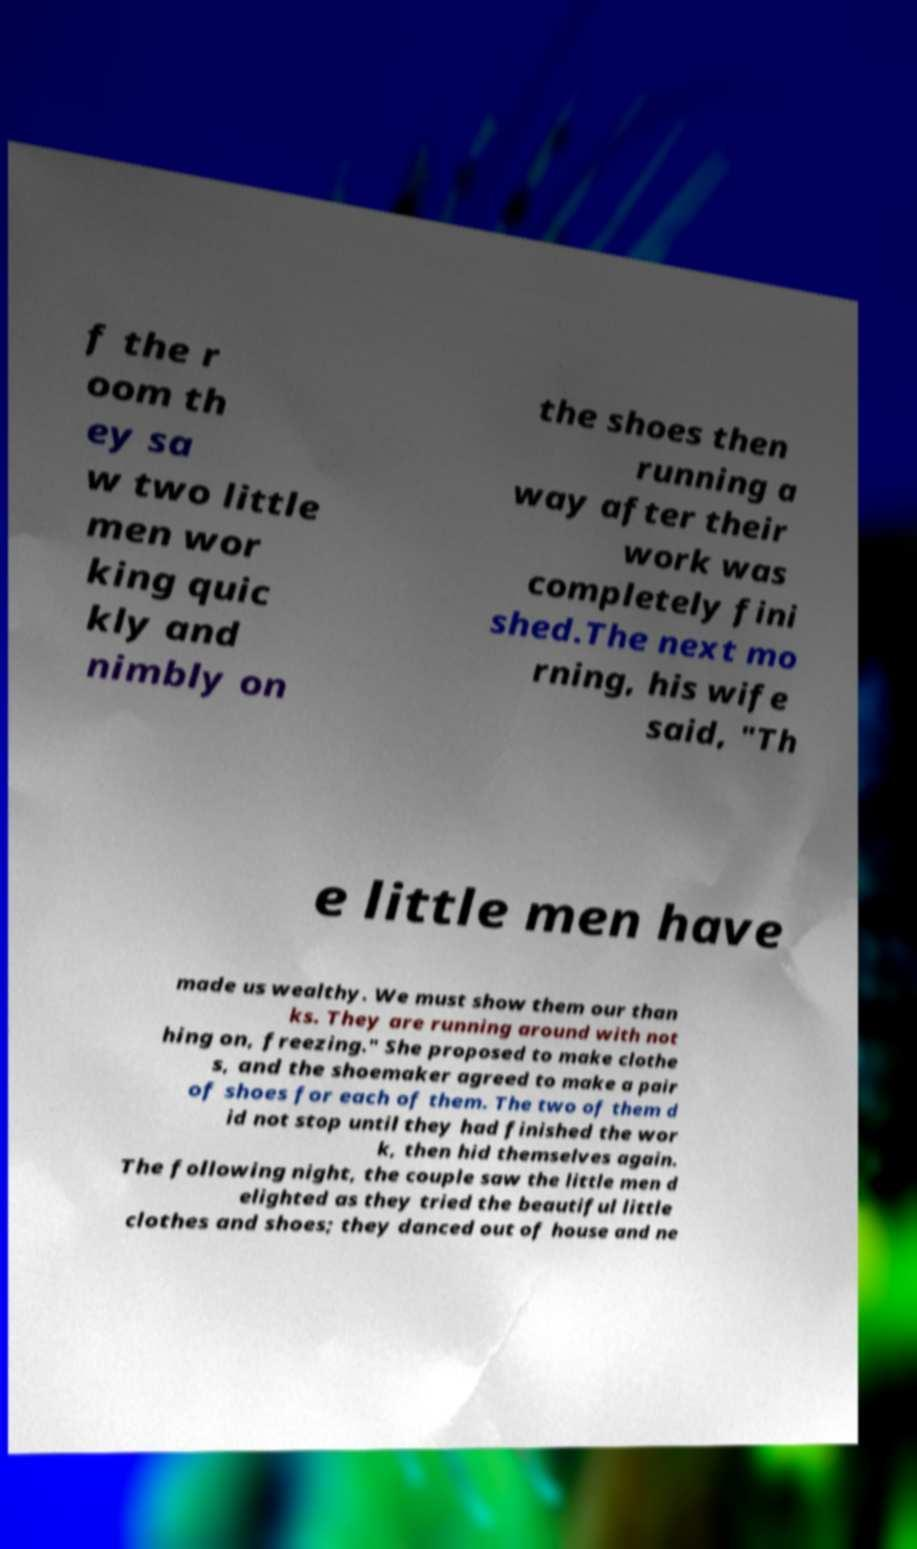What messages or text are displayed in this image? I need them in a readable, typed format. f the r oom th ey sa w two little men wor king quic kly and nimbly on the shoes then running a way after their work was completely fini shed.The next mo rning, his wife said, "Th e little men have made us wealthy. We must show them our than ks. They are running around with not hing on, freezing." She proposed to make clothe s, and the shoemaker agreed to make a pair of shoes for each of them. The two of them d id not stop until they had finished the wor k, then hid themselves again. The following night, the couple saw the little men d elighted as they tried the beautiful little clothes and shoes; they danced out of house and ne 